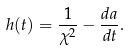Convert formula to latex. <formula><loc_0><loc_0><loc_500><loc_500>h ( t ) = \frac { 1 } { \chi ^ { 2 } } - \frac { d a } { d t } .</formula> 